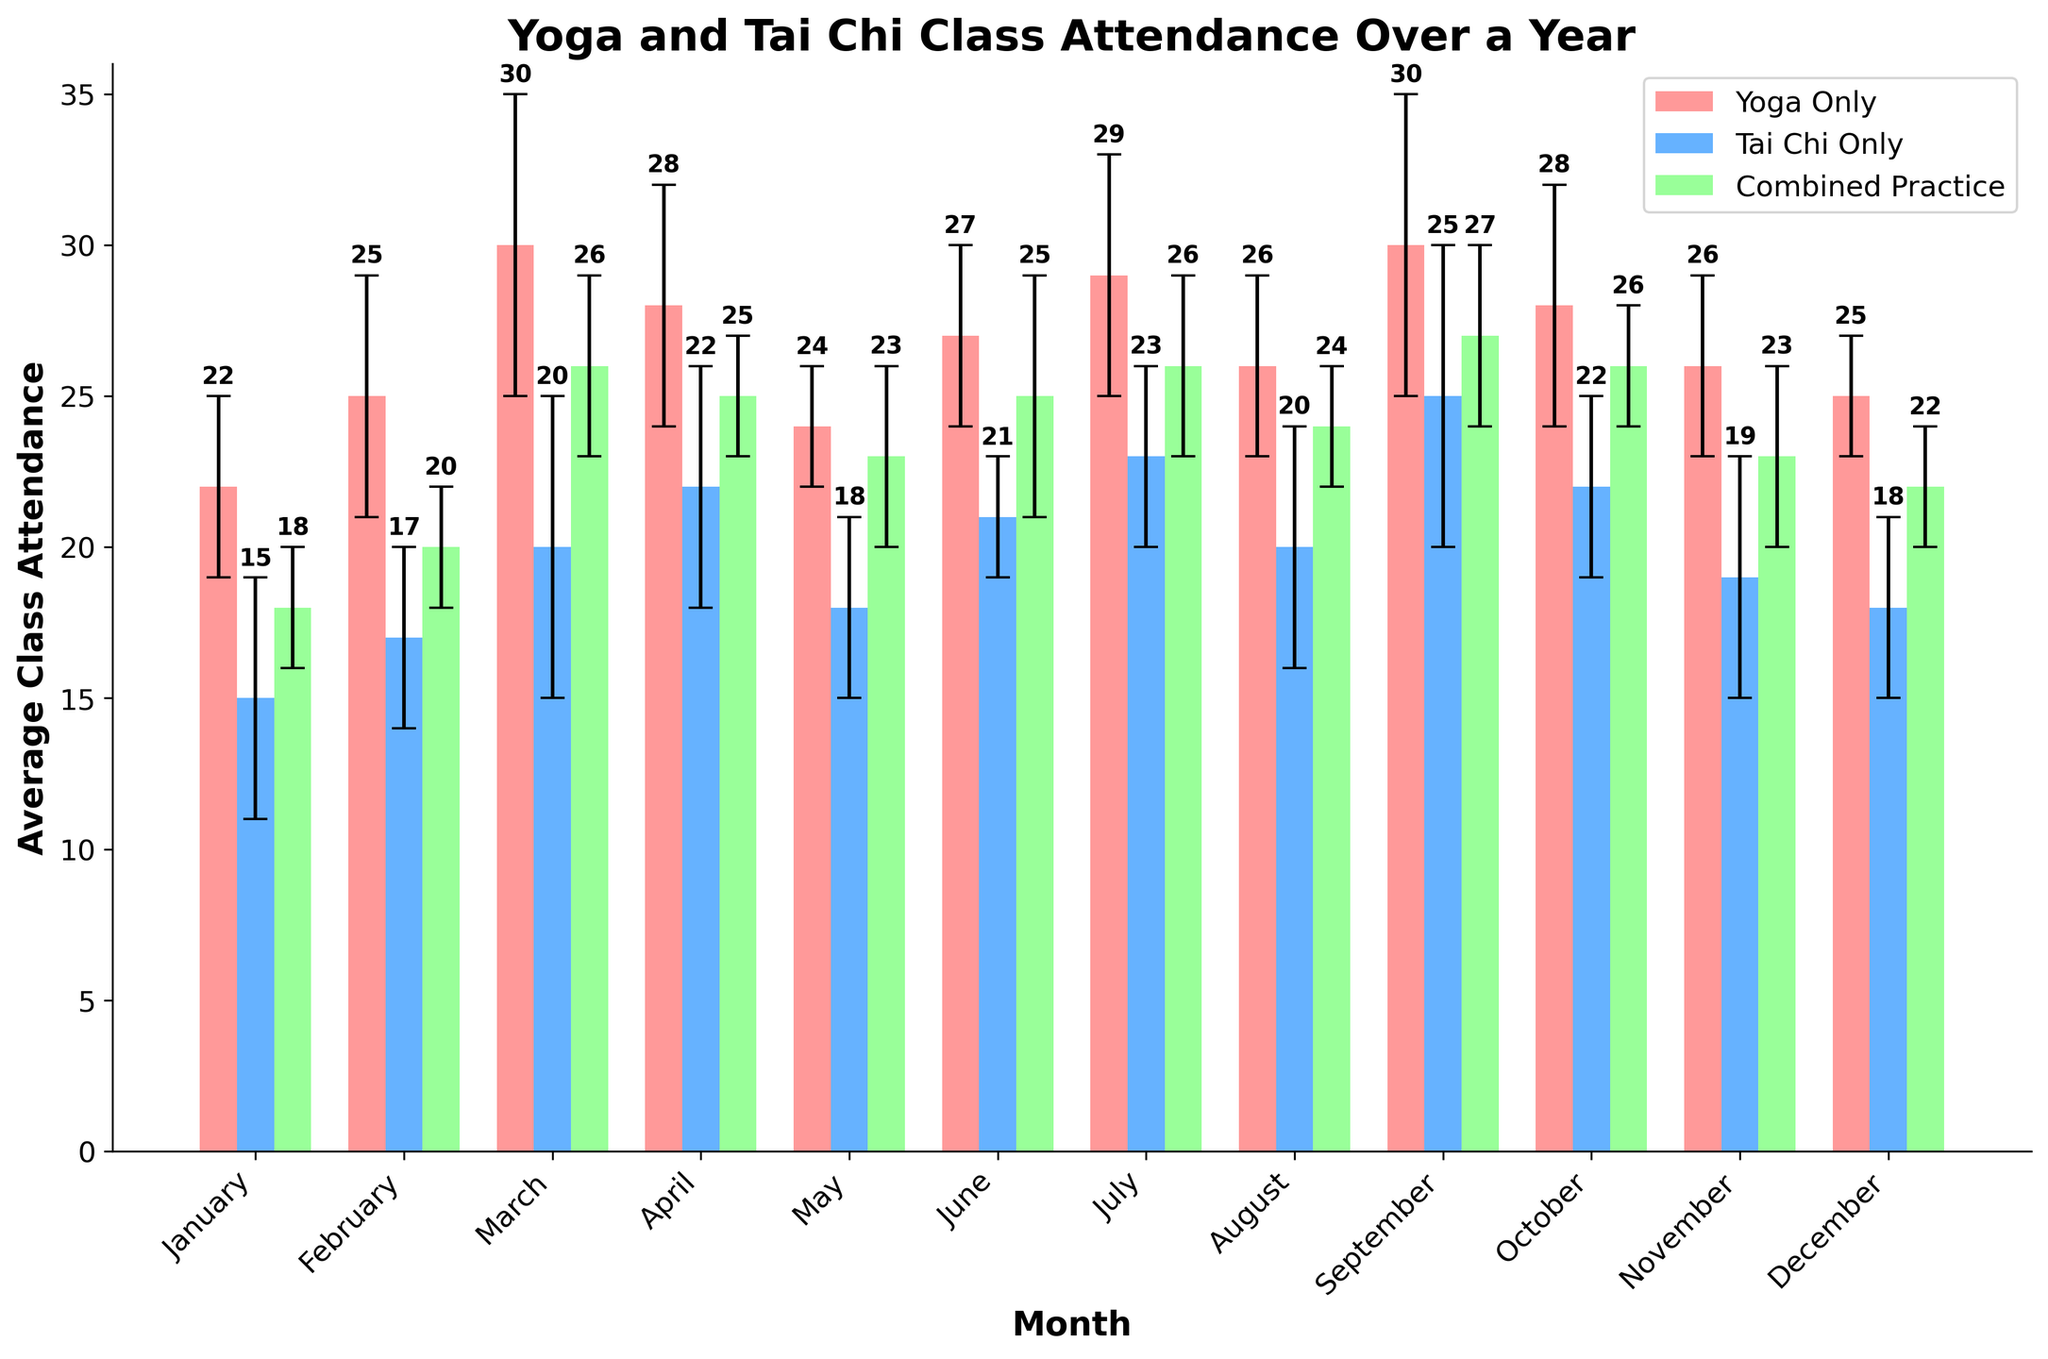What is the average class attendance for yoga-only sessions in March? Look at the March bar for Yoga Only. The height of the bar represents the average attendance for that month.
Answer: 30 Which practice type had the highest class attendance on average in April? Look at April's bars for Yoga Only, Tai Chi Only, and Combined Practice. The bar with the highest value represents the highest average attendance.
Answer: Yoga Only How much did attendance for Tai Chi Only classes vary in July? Look at July's Tai Chi Only bar and the error bar representing the variability (standard deviation). The value of the error bar indicates the variability.
Answer: 3 In which month did the combined practice sessions have the lowest average attendance? Compare the heights of the combined practice bars for all months. The shortest bar represents the month with the lowest average attendance.
Answer: January What is the range of average attendance for yoga-only sessions across all months? Find the minimum and maximum average attendance for Yoga Only across all months. The range is calculated as the maximum minus the minimum.
Answer: 30 - 22 = 8 By how much did the average attendance for Tai Chi Only classes change between February and March? Look at the bars for Tai Chi Only in February and March. Subtract the February value from the March value to find the change.
Answer: 20 - 17 = 3 How many months showed a higher average attendance for combined practice compared to yoga-only sessions? For each month, compare the height of the Combined Practice bar to the Yoga Only bar and count the number of months where Combined Practice is higher.
Answer: 0 What is the total average attendance for Yoga Only sessions over the year? Add the values of the Yoga Only bars for all months.
Answer: 22 + 25 + 30 + 28 + 24 + 27 + 29 + 26 + 30 + 28 + 26 + 25 = 320 How much higher is the average attendance of yoga-only sessions in September compared to Tai Chi Only sessions? Subtract the average attendance for Tai Chi Only in September from Yoga Only in September.
Answer: 30 - 25 = 5 Which month had the smallest variability in combined practice sessions? Compare the error bars for Combined Practice across all months. The month with the smallest error bar represents the smallest variability.
Answer: January 